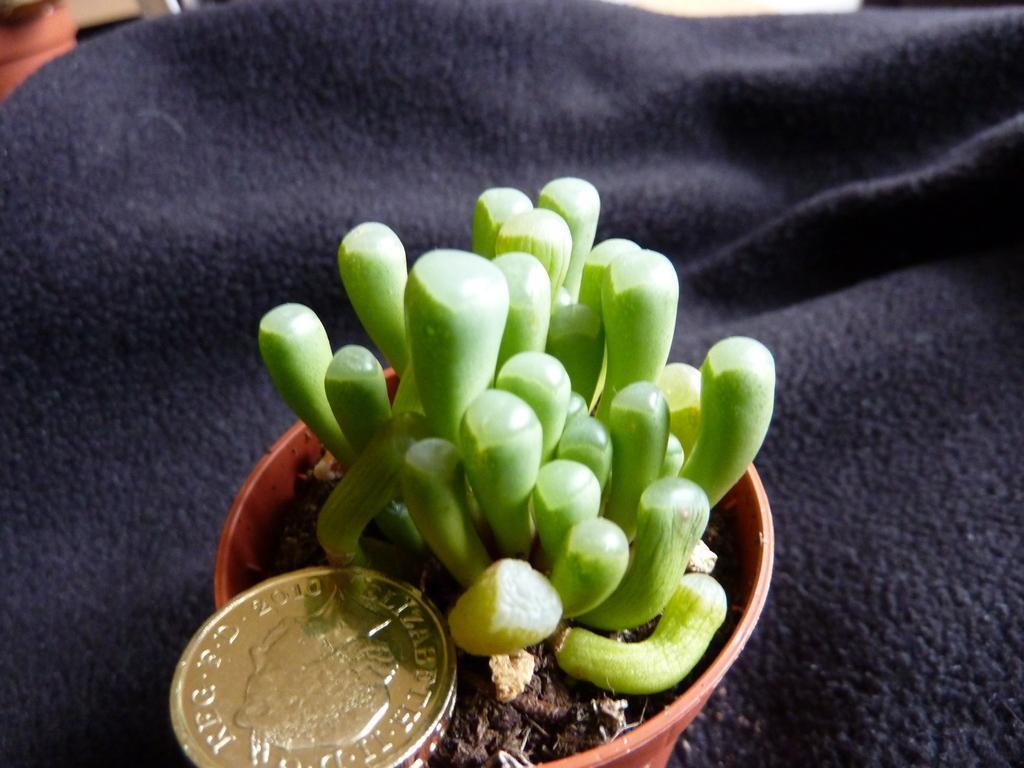In one or two sentences, can you explain what this image depicts? In the picture I can see the plant pot and I can see the coin. It is looking like a blanket. 